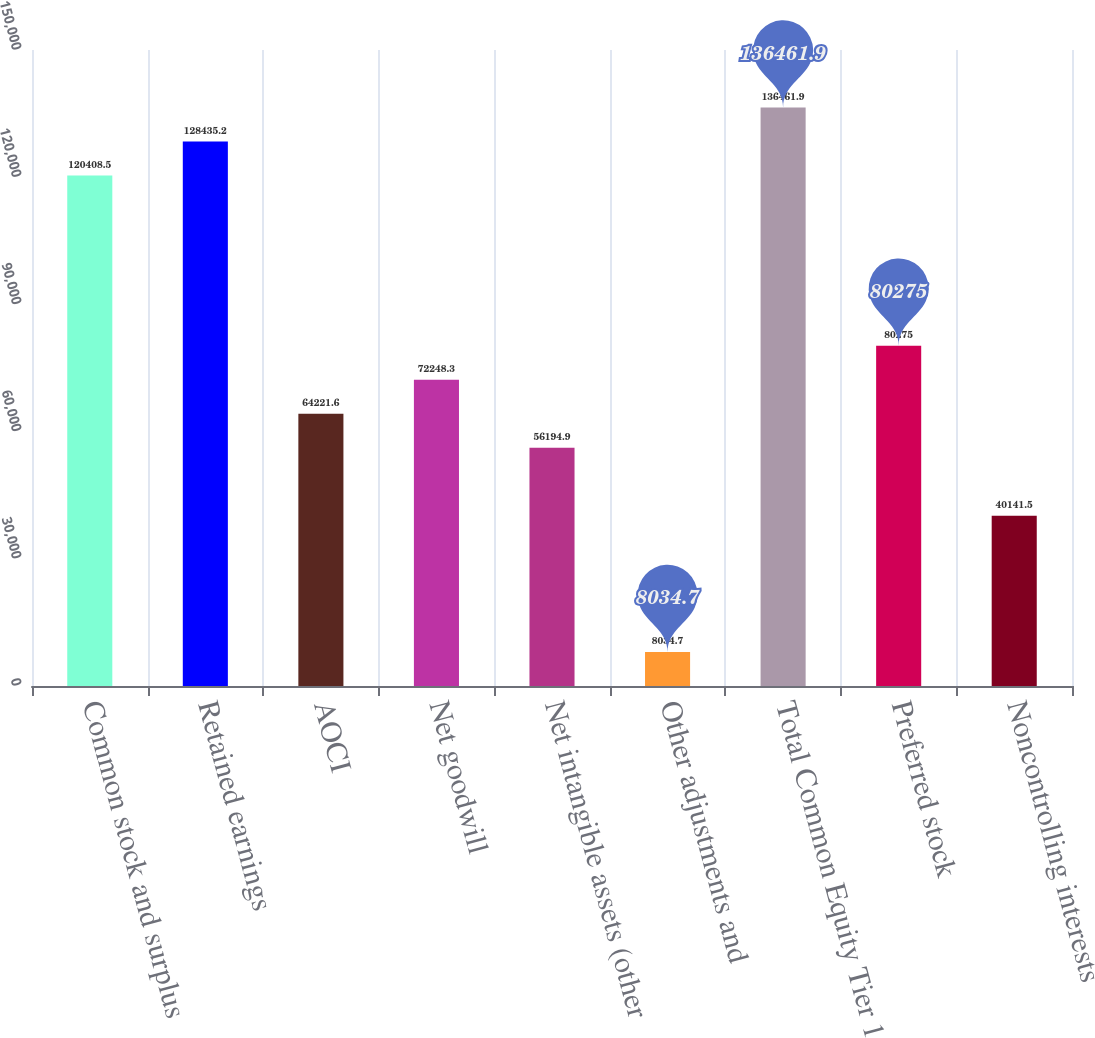Convert chart. <chart><loc_0><loc_0><loc_500><loc_500><bar_chart><fcel>Common stock and surplus<fcel>Retained earnings<fcel>AOCI<fcel>Net goodwill<fcel>Net intangible assets (other<fcel>Other adjustments and<fcel>Total Common Equity Tier 1<fcel>Preferred stock<fcel>Noncontrolling interests<nl><fcel>120408<fcel>128435<fcel>64221.6<fcel>72248.3<fcel>56194.9<fcel>8034.7<fcel>136462<fcel>80275<fcel>40141.5<nl></chart> 